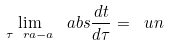<formula> <loc_0><loc_0><loc_500><loc_500>\lim _ { \tau \ r a - a } \ a b s { \frac { d t } { d \tau } } = \ u n</formula> 